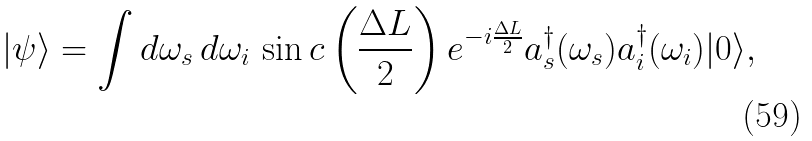Convert formula to latex. <formula><loc_0><loc_0><loc_500><loc_500>| \psi \rangle = \int d \omega _ { s } \, d \omega _ { i } \, \sin c \left ( \frac { \Delta L } { 2 } \right ) e ^ { - i \frac { \Delta L } { 2 } } a ^ { \dagger } _ { s } ( \omega _ { s } ) a ^ { \dagger } _ { i } ( \omega _ { i } ) | 0 \rangle ,</formula> 